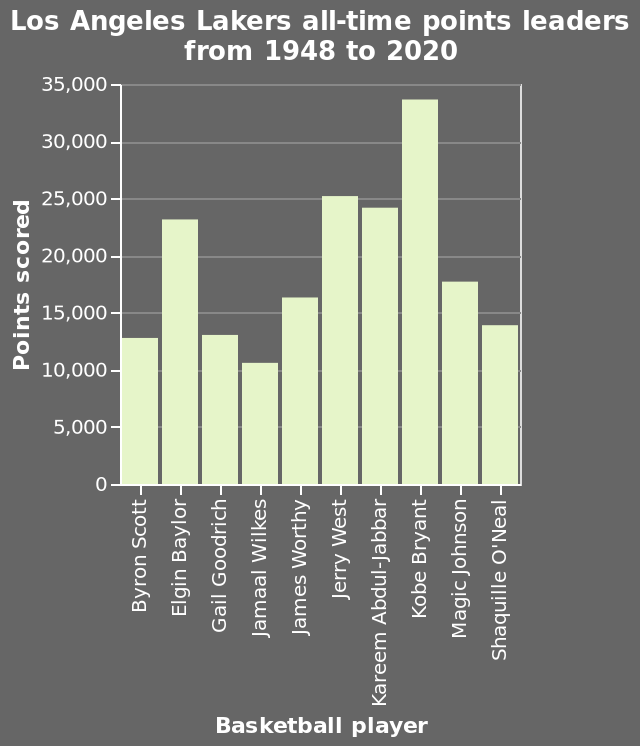<image>
please describe the details of the chart Here a bar diagram is titled Los Angeles Lakers all-time points leaders from 1948 to 2020. The x-axis plots Basketball player while the y-axis plots Points scored. What does the y-axis of the bar diagram represent? The y-axis of the bar diagram represents Points scored. 